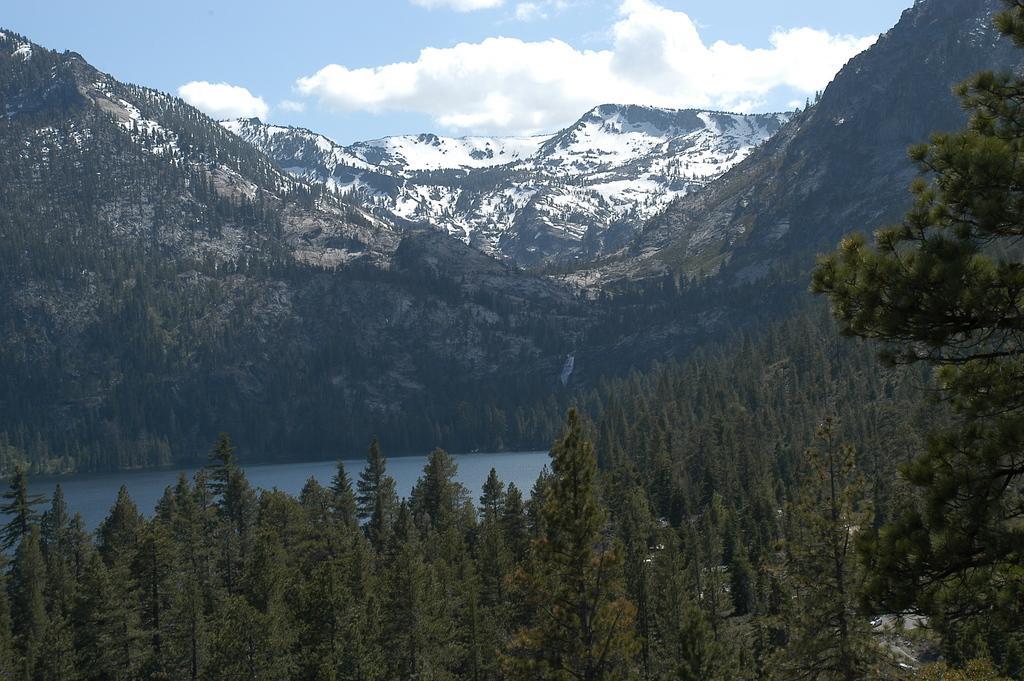Could you give a brief overview of what you see in this image? In this image there are trees, behind the trees there is a river, behind the river there are mountains. At the top of the image there are clouds in the sky. 